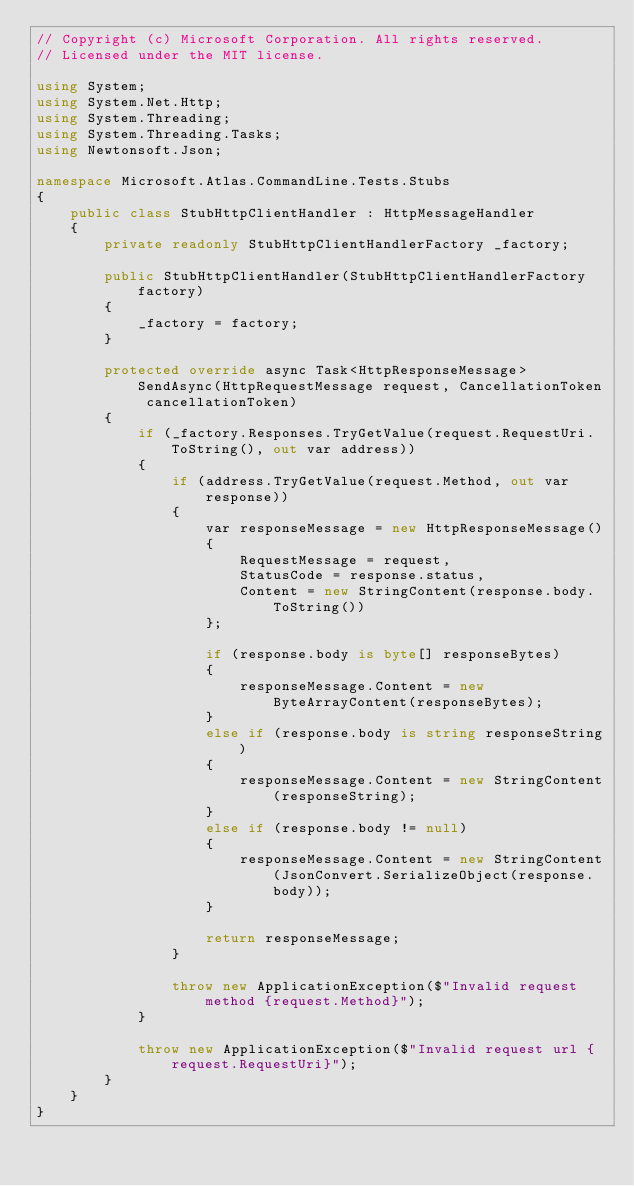Convert code to text. <code><loc_0><loc_0><loc_500><loc_500><_C#_>// Copyright (c) Microsoft Corporation. All rights reserved.
// Licensed under the MIT license.

using System;
using System.Net.Http;
using System.Threading;
using System.Threading.Tasks;
using Newtonsoft.Json;

namespace Microsoft.Atlas.CommandLine.Tests.Stubs
{
    public class StubHttpClientHandler : HttpMessageHandler
    {
        private readonly StubHttpClientHandlerFactory _factory;

        public StubHttpClientHandler(StubHttpClientHandlerFactory factory)
        {
            _factory = factory;
        }

        protected override async Task<HttpResponseMessage> SendAsync(HttpRequestMessage request, CancellationToken cancellationToken)
        {
            if (_factory.Responses.TryGetValue(request.RequestUri.ToString(), out var address))
            {
                if (address.TryGetValue(request.Method, out var response))
                {
                    var responseMessage = new HttpResponseMessage()
                    {
                        RequestMessage = request,
                        StatusCode = response.status,
                        Content = new StringContent(response.body.ToString())
                    };

                    if (response.body is byte[] responseBytes)
                    {
                        responseMessage.Content = new ByteArrayContent(responseBytes);
                    }
                    else if (response.body is string responseString)
                    {
                        responseMessage.Content = new StringContent(responseString);
                    }
                    else if (response.body != null)
                    {
                        responseMessage.Content = new StringContent(JsonConvert.SerializeObject(response.body));
                    }

                    return responseMessage;
                }

                throw new ApplicationException($"Invalid request method {request.Method}");
            }

            throw new ApplicationException($"Invalid request url {request.RequestUri}");
        }
    }
}
</code> 